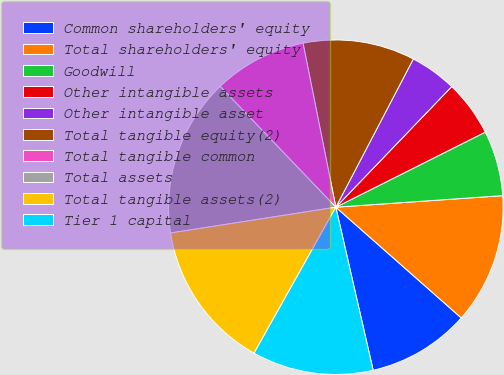<chart> <loc_0><loc_0><loc_500><loc_500><pie_chart><fcel>Common shareholders' equity<fcel>Total shareholders' equity<fcel>Goodwill<fcel>Other intangible assets<fcel>Other intangible asset<fcel>Total tangible equity(2)<fcel>Total tangible common<fcel>Total assets<fcel>Total tangible assets(2)<fcel>Tier 1 capital<nl><fcel>9.91%<fcel>12.61%<fcel>6.31%<fcel>5.41%<fcel>4.51%<fcel>10.81%<fcel>9.01%<fcel>15.31%<fcel>14.41%<fcel>11.71%<nl></chart> 